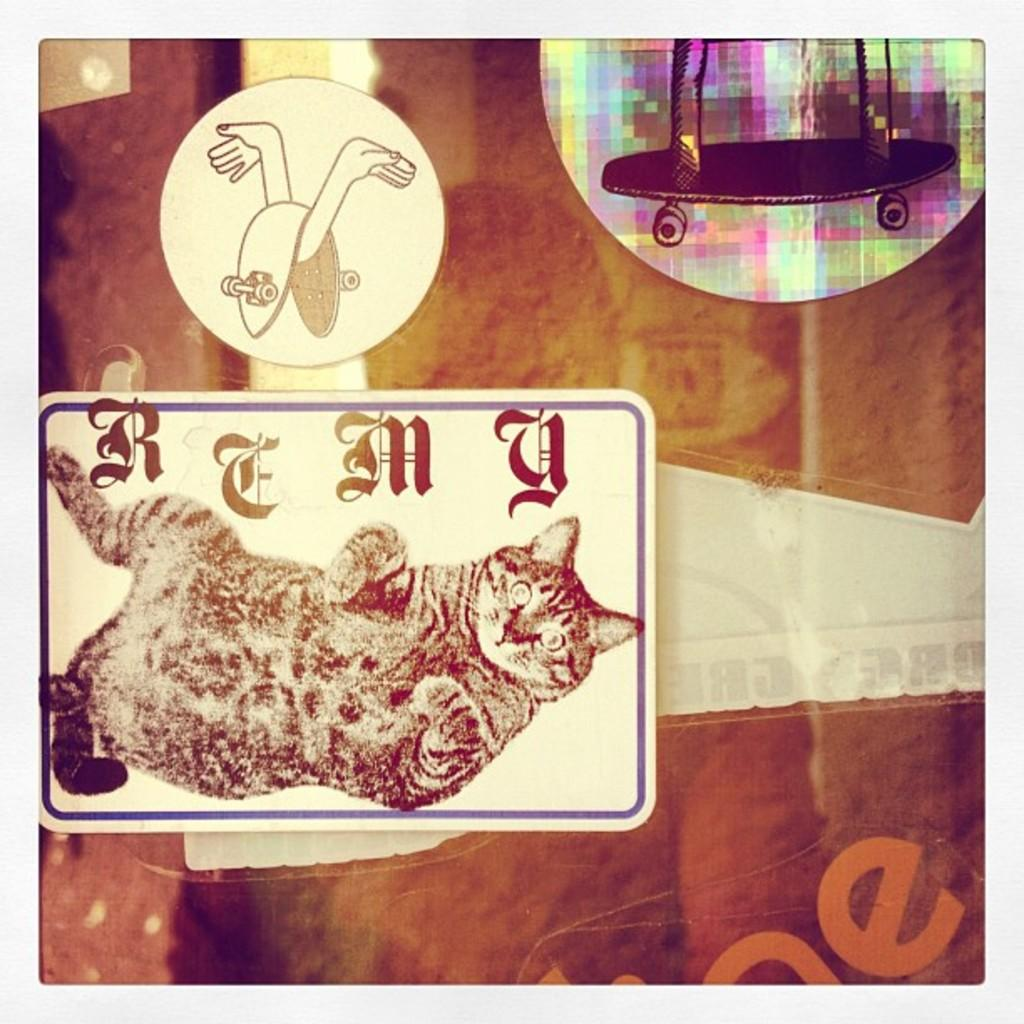What is the main object in the image? There is a board in the image. What can be seen on the board? There are drawings in the image. What type of cheese is being used to join the drawings together in the image? There is no cheese present in the image, and the drawings are not being joined together with any type of cheese. 